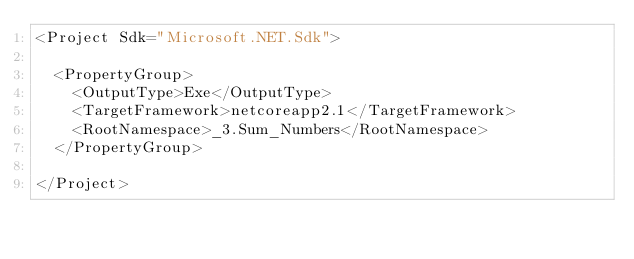<code> <loc_0><loc_0><loc_500><loc_500><_XML_><Project Sdk="Microsoft.NET.Sdk">

  <PropertyGroup>
    <OutputType>Exe</OutputType>
    <TargetFramework>netcoreapp2.1</TargetFramework>
    <RootNamespace>_3.Sum_Numbers</RootNamespace>
  </PropertyGroup>

</Project>
</code> 